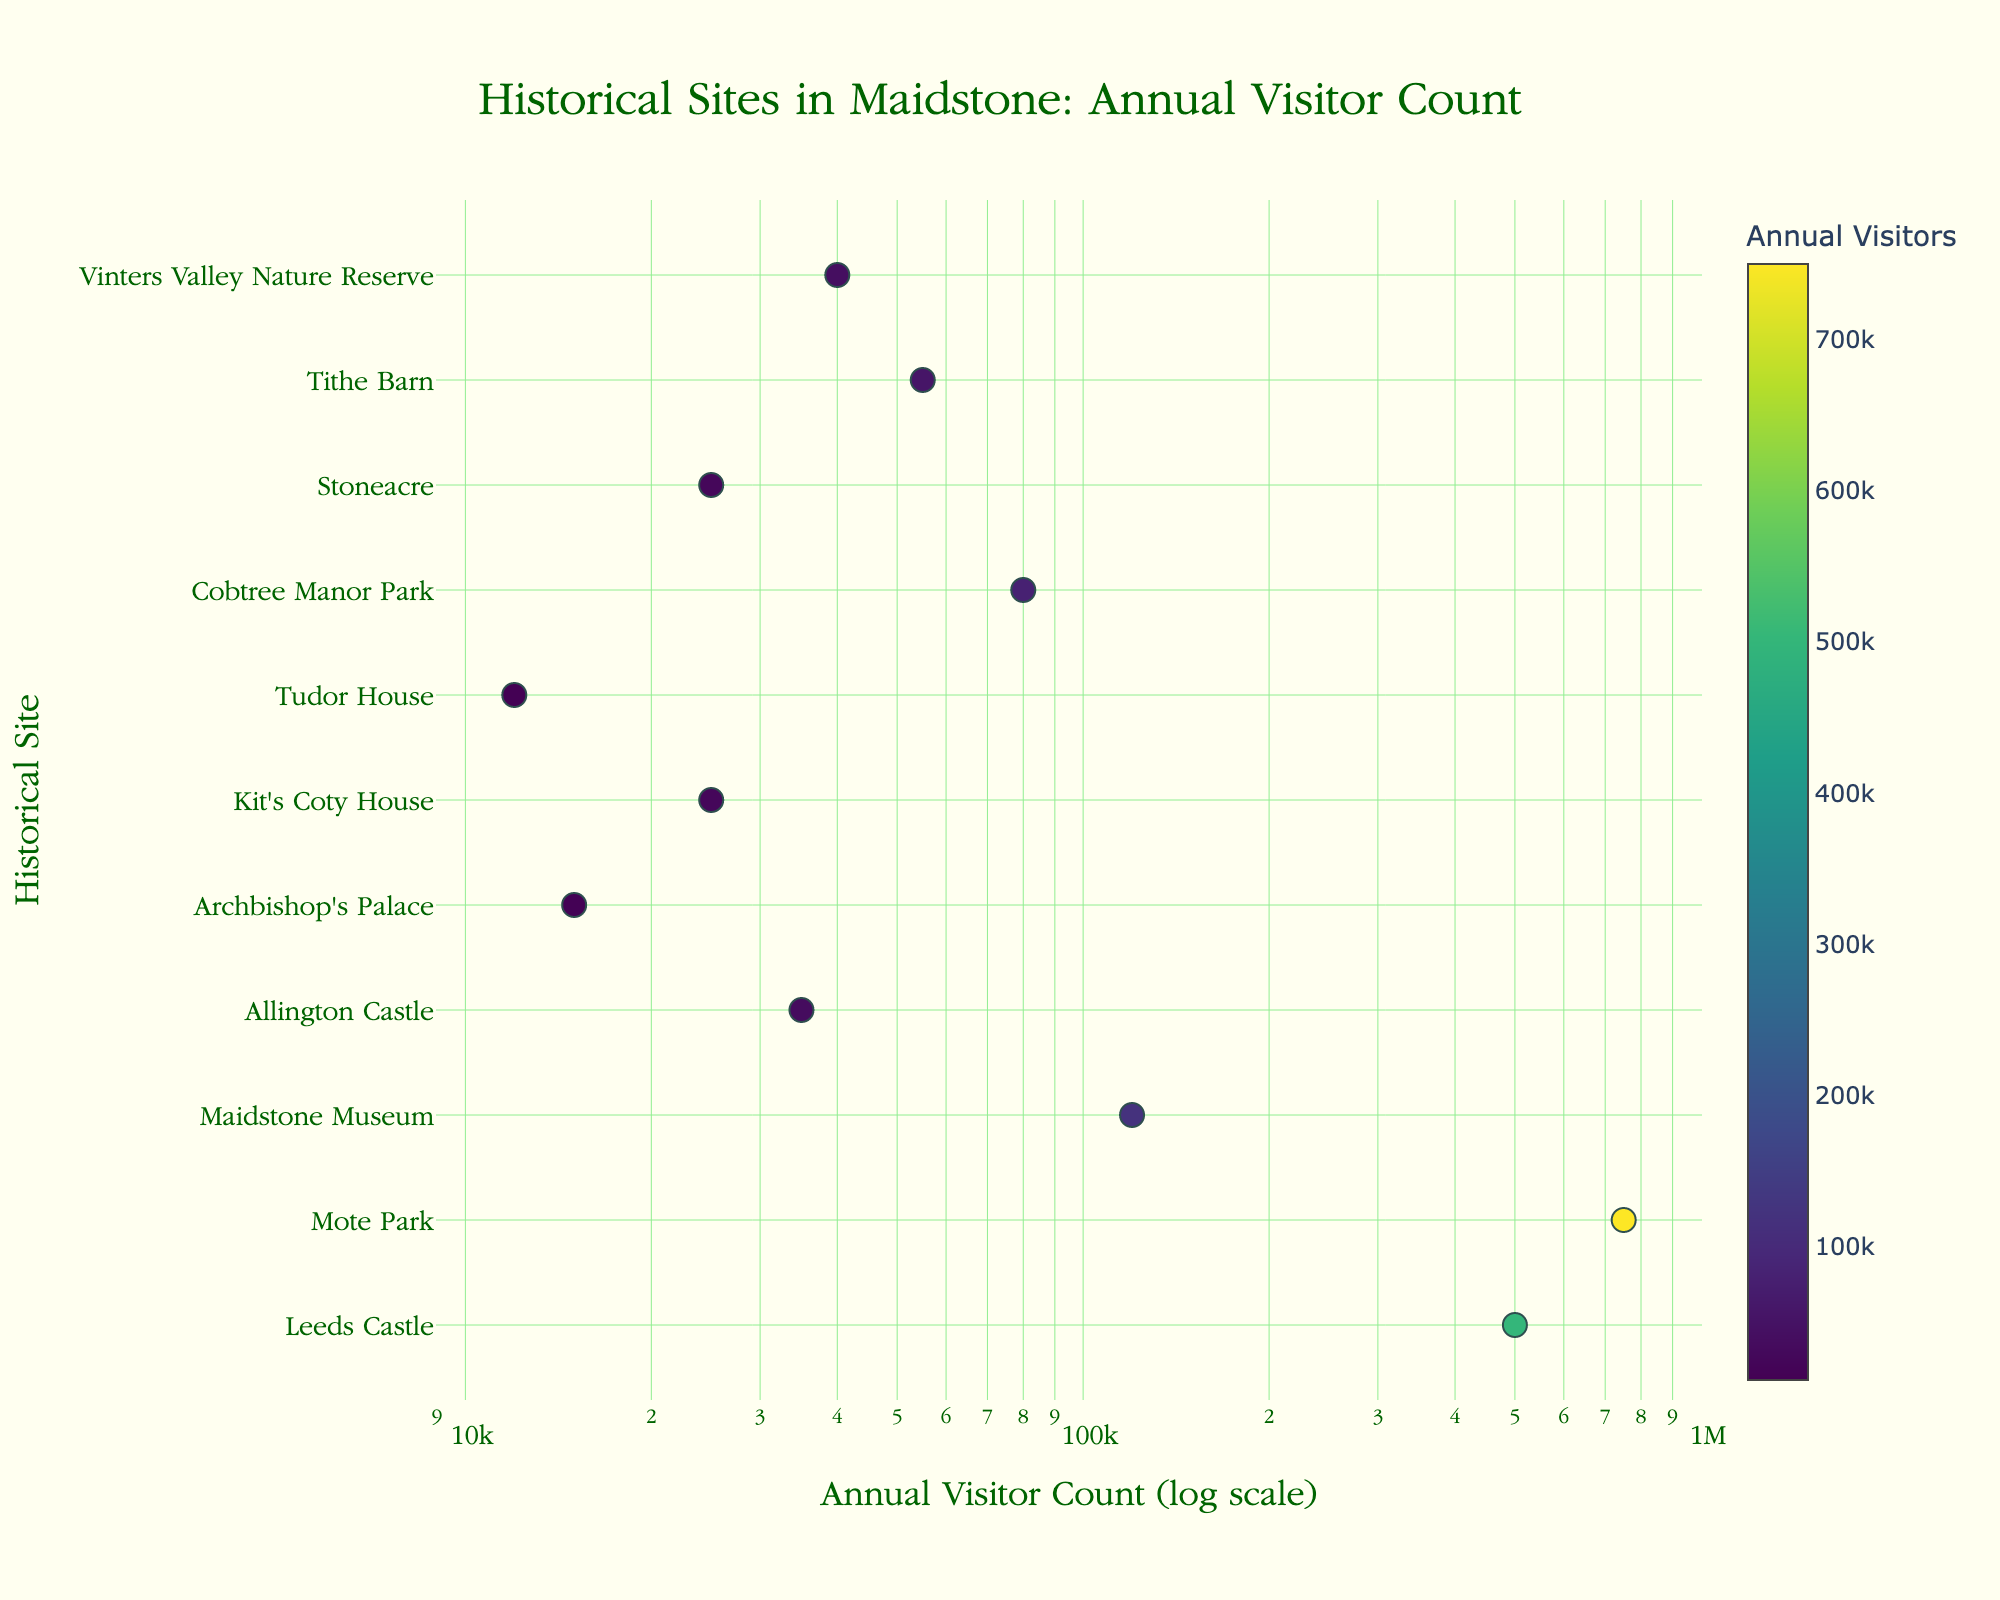How many historical sites attract more than 100,000 visitors annually? By inspecting the log-scaled x-axis and the plotted data points, we count the number of sites with visitor counts located to the right of the 100,000 mark.
Answer: 3 Which historical site has the highest number of annual visitors? Identify the data point farthest to the right on the x-axis representing the log scale of annual visitor count.
Answer: Mote Park Compared to Tithe Barn, how many more annual visitors does Leeds Castle have? Determine the annual visitor count for both sites (Tithe Barn: 55,000, Leeds Castle: 500,000). Subtract Tithe Barn's visitors from Leeds Castle's visitors (500,000 - 55,000).
Answer: 445,000 Which site has the lowest number of annual visitors? Locate the data point closest to the left on the x-axis, signifying the lowest visitor count on the log scale.
Answer: Tudor House What is the median value of annual visitors among the historical sites in Maidstone? List the annual visitor counts, then find the middle value when they are ordered numerically: 12,000; 15,000; 25,000; 25,000; 35,000; 40,000; 55,000; 80,000; 120,000; 500,000; 750,000. The median is the middle value.
Answer: 35,000 How does the visitor count of Mote Park compare to Maidstone Museum? Compare the x-values (annual visitor counts) for Mote Park (750,000) and Maidstone Museum (120,000). Mote Park has a significantly higher visitor count.
Answer: Higher What percentage of the total annual visitors does Cobtree Manor Park represent if you sum all visitors? First, sum all annual visitor counts. Then divide Cobtree Manor Park's visitor count (80,000) by the total and multiply by 100.
Answer: Approximately 7.14% What is the ratio of visitors between Mote Park and Archbishop's Palace? Divide Mote Park's annual visitors (750,000) by Archbishop's Palace's visitors (15,000) to get the ratio.
Answer: 50:1 Is there a positive correlation between the number of annual visitors and the historical significance of the sites in Maidstone? By analyzing the scatter plot visually, determine whether there is a pattern where historically significant sites tend to have higher visitor counts.
Answer: Yes Which site, Leeds Castle or Vinters Valley Nature Reserve, attracts more visitors? By comparing the x-axis positions of both sites in the scatter plot, determine which one is further right (Leeds Castle: 500,000, Vinters Valley Nature Reserve: 40,000).
Answer: Leeds Castle 